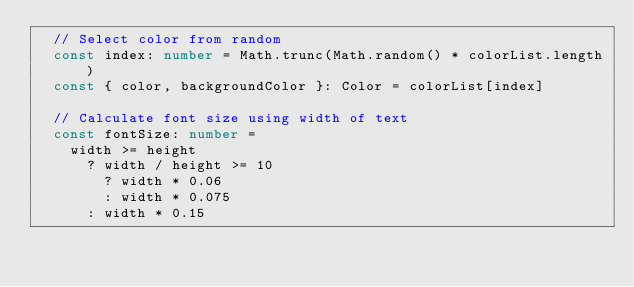Convert code to text. <code><loc_0><loc_0><loc_500><loc_500><_TypeScript_>  // Select color from random
  const index: number = Math.trunc(Math.random() * colorList.length)
  const { color, backgroundColor }: Color = colorList[index]

  // Calculate font size using width of text
  const fontSize: number =
    width >= height
      ? width / height >= 10
        ? width * 0.06
        : width * 0.075
      : width * 0.15
</code> 